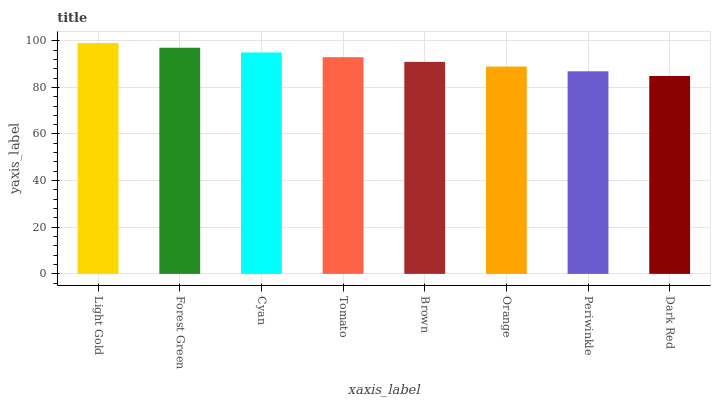Is Dark Red the minimum?
Answer yes or no. Yes. Is Light Gold the maximum?
Answer yes or no. Yes. Is Forest Green the minimum?
Answer yes or no. No. Is Forest Green the maximum?
Answer yes or no. No. Is Light Gold greater than Forest Green?
Answer yes or no. Yes. Is Forest Green less than Light Gold?
Answer yes or no. Yes. Is Forest Green greater than Light Gold?
Answer yes or no. No. Is Light Gold less than Forest Green?
Answer yes or no. No. Is Tomato the high median?
Answer yes or no. Yes. Is Brown the low median?
Answer yes or no. Yes. Is Forest Green the high median?
Answer yes or no. No. Is Light Gold the low median?
Answer yes or no. No. 